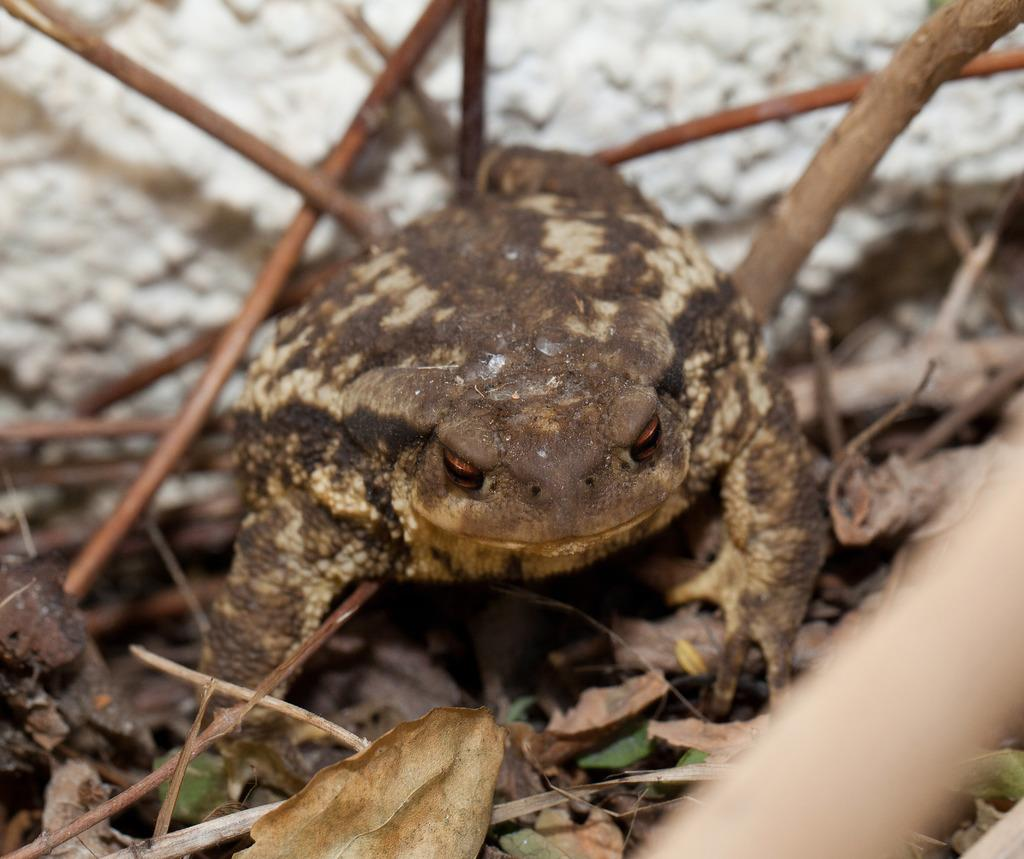What type of animal is in the image? There is a frog in the image. Where is the frog located? The frog is on stems in the image. What else can be seen in the image besides the frog? Leaves are present in the image. Can you describe any other elements in the image? There are other unspecified things in the image. What is the frog feeling during the meeting in the image? There is no meeting depicted in the image, and therefore no indication of the frog's emotions. How does the frog's stomach appear in the image? The image does not show the frog's stomach, so it cannot be described. 